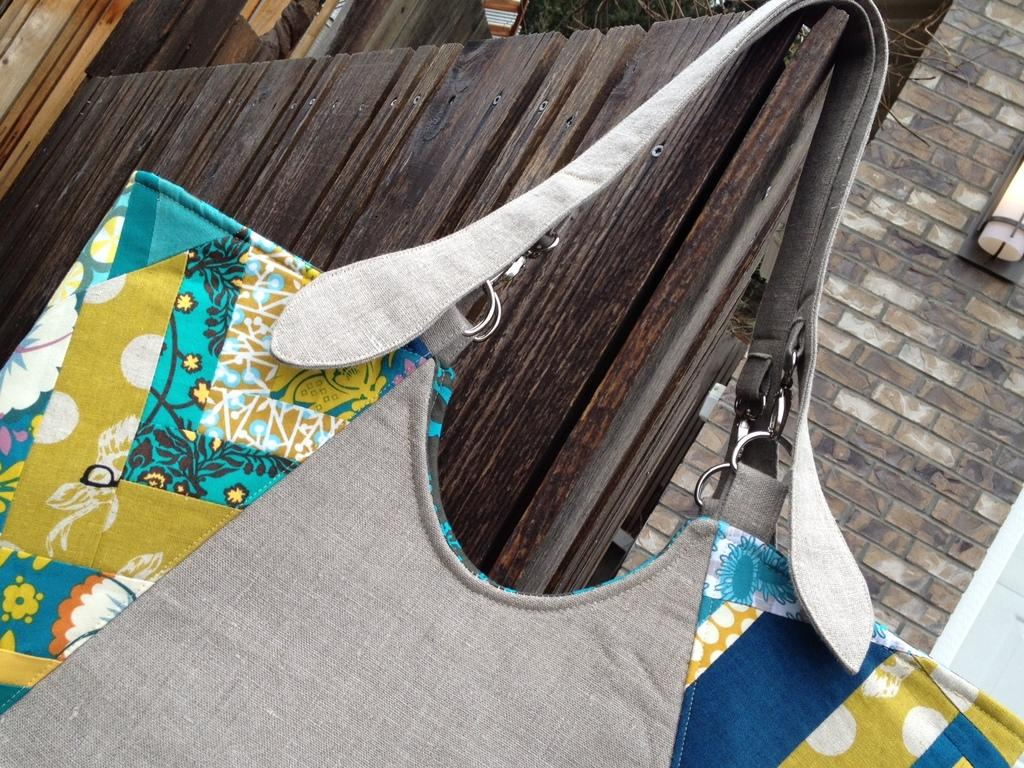What object is hanging on the door in the image? There is a handbag hanging on a door in the image. What degree does the handbag have in the image? The handbag does not have a degree, as it is an inanimate object and cannot obtain a degree. 